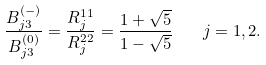Convert formula to latex. <formula><loc_0><loc_0><loc_500><loc_500>\frac { B _ { j 3 } ^ { ( - ) } } { B _ { j 3 } ^ { ( 0 ) } } = \frac { R _ { j } ^ { 1 1 } } { R _ { j } ^ { 2 2 } } = \frac { 1 + \sqrt { 5 } } { 1 - \sqrt { 5 } } \quad j = 1 , 2 .</formula> 